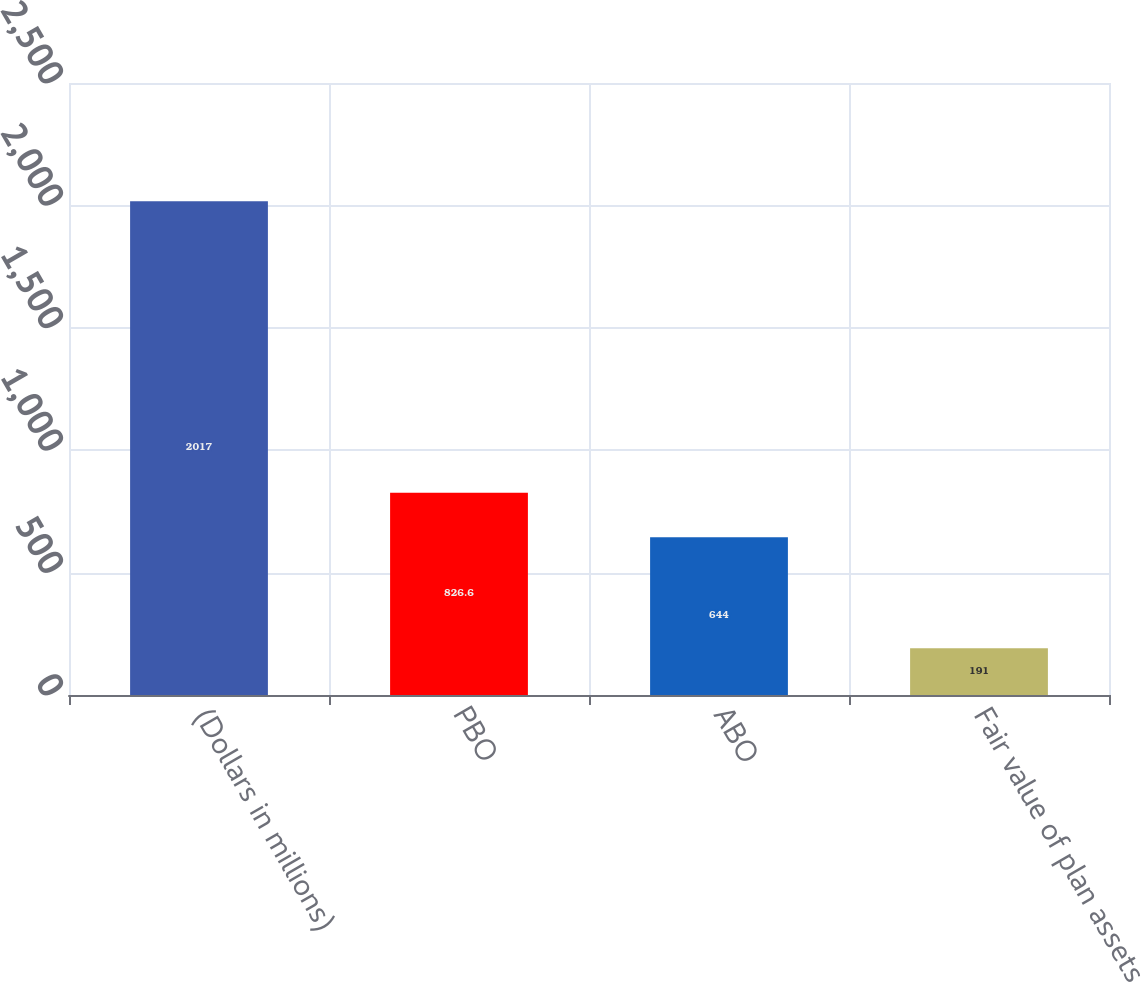Convert chart to OTSL. <chart><loc_0><loc_0><loc_500><loc_500><bar_chart><fcel>(Dollars in millions)<fcel>PBO<fcel>ABO<fcel>Fair value of plan assets<nl><fcel>2017<fcel>826.6<fcel>644<fcel>191<nl></chart> 